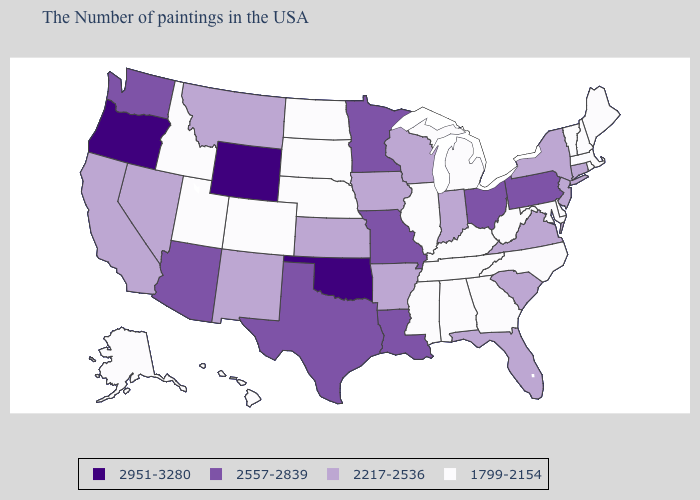What is the highest value in the USA?
Be succinct. 2951-3280. Does Georgia have the lowest value in the South?
Answer briefly. Yes. How many symbols are there in the legend?
Concise answer only. 4. Name the states that have a value in the range 2951-3280?
Write a very short answer. Oklahoma, Wyoming, Oregon. Which states have the lowest value in the South?
Be succinct. Delaware, Maryland, North Carolina, West Virginia, Georgia, Kentucky, Alabama, Tennessee, Mississippi. Name the states that have a value in the range 2217-2536?
Give a very brief answer. Connecticut, New York, New Jersey, Virginia, South Carolina, Florida, Indiana, Wisconsin, Arkansas, Iowa, Kansas, New Mexico, Montana, Nevada, California. What is the highest value in states that border New York?
Answer briefly. 2557-2839. What is the highest value in the USA?
Give a very brief answer. 2951-3280. Among the states that border Utah , which have the lowest value?
Short answer required. Colorado, Idaho. Does Mississippi have the same value as Louisiana?
Quick response, please. No. Name the states that have a value in the range 2557-2839?
Write a very short answer. Pennsylvania, Ohio, Louisiana, Missouri, Minnesota, Texas, Arizona, Washington. Among the states that border Missouri , which have the lowest value?
Concise answer only. Kentucky, Tennessee, Illinois, Nebraska. What is the value of Nevada?
Quick response, please. 2217-2536. Does Arizona have a lower value than Ohio?
Give a very brief answer. No. What is the value of Connecticut?
Write a very short answer. 2217-2536. 